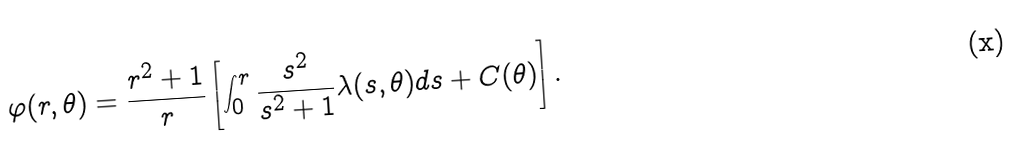Convert formula to latex. <formula><loc_0><loc_0><loc_500><loc_500>\varphi ( r , \theta ) = \frac { r ^ { 2 } + 1 } { r } \left [ \int _ { 0 } ^ { r } \frac { s ^ { 2 } } { s ^ { 2 } + 1 } \lambda ( s , \theta ) d s + C ( \theta ) \right ] .</formula> 